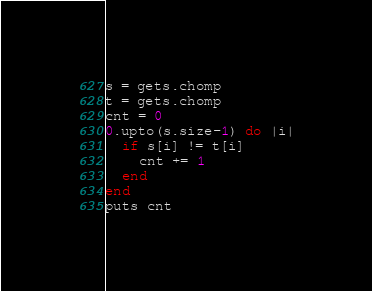<code> <loc_0><loc_0><loc_500><loc_500><_Ruby_>s = gets.chomp
t = gets.chomp
cnt = 0
0.upto(s.size-1) do |i|
  if s[i] != t[i]
    cnt += 1
  end
end
puts cnt</code> 